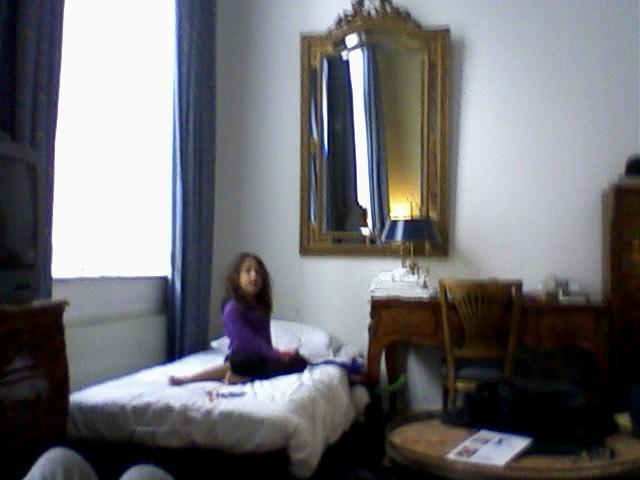Why is the image blurred?

Choices:
A) shaky photographer
B) unfocussed
C) girl moving
D) broken camera unfocussed 